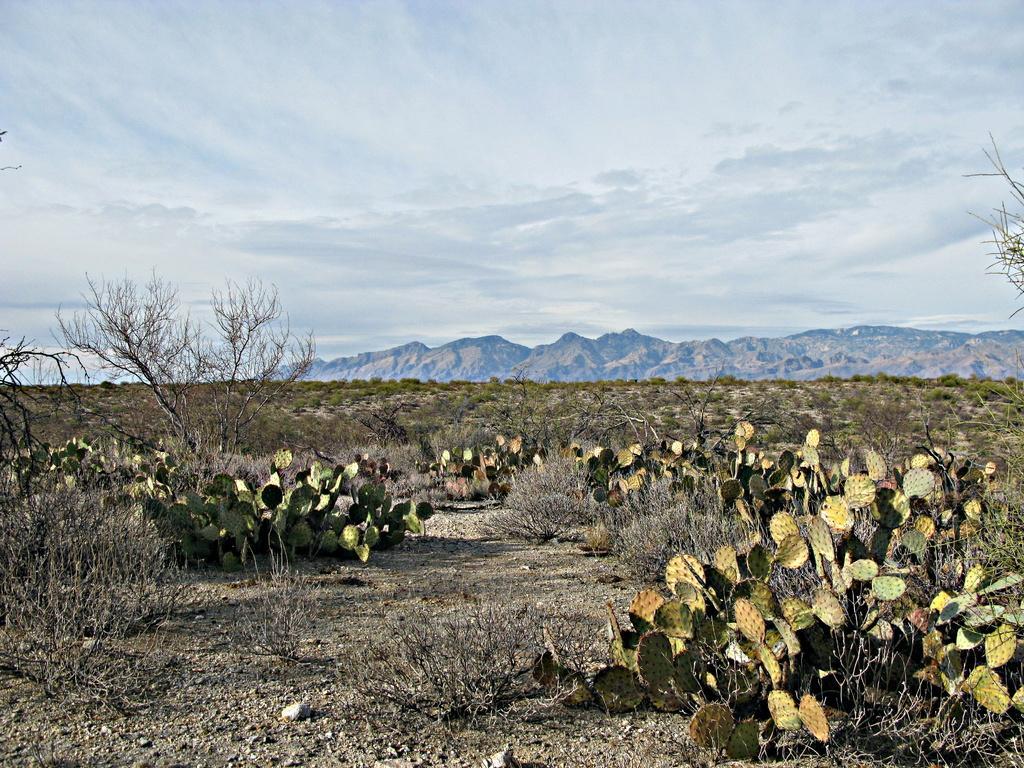How would you summarize this image in a sentence or two? Here in this picture we can see cactus plants present on the ground and we can also see other trees present and in the far we can see other planets also present and we can see mountains present in the far and we can see clouds in the sky. 